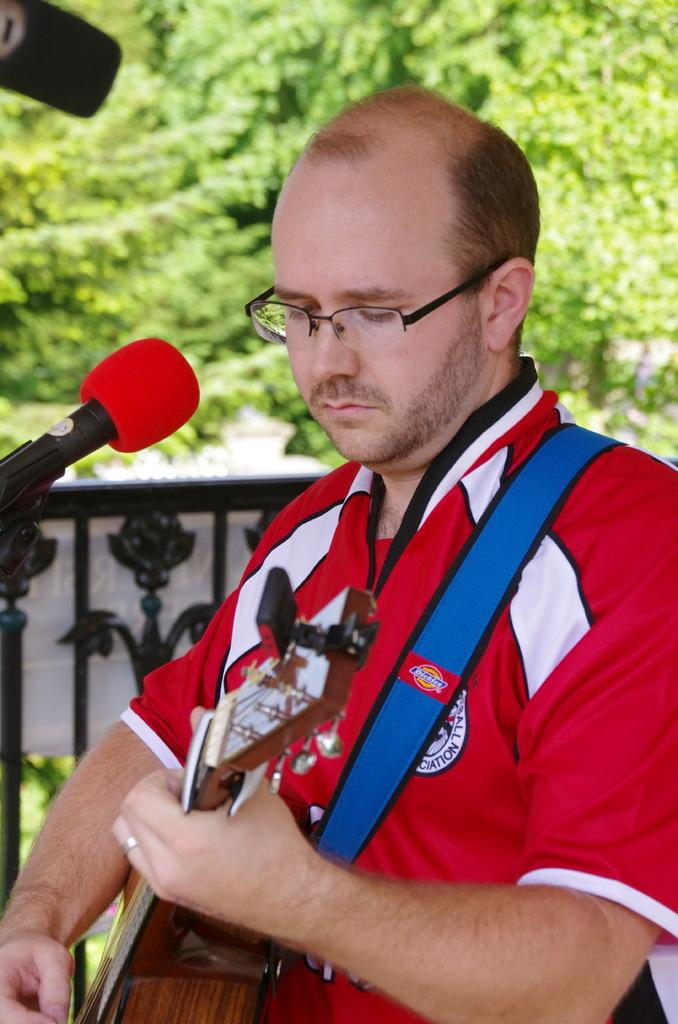What is the person in the image doing? The person is playing the guitar. How is the person positioned in the image? The person is standing. What object is present in the image that is typically used for amplifying sound? There is a microphone in the image. What can be seen in the background of the image? Trees are visible in the background of the image. What type of wind can be seen blowing through the guitar strings in the image? There is no wind present in the image; the guitar strings are not being blown by any wind. 